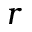Convert formula to latex. <formula><loc_0><loc_0><loc_500><loc_500>r</formula> 